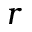Convert formula to latex. <formula><loc_0><loc_0><loc_500><loc_500>r</formula> 